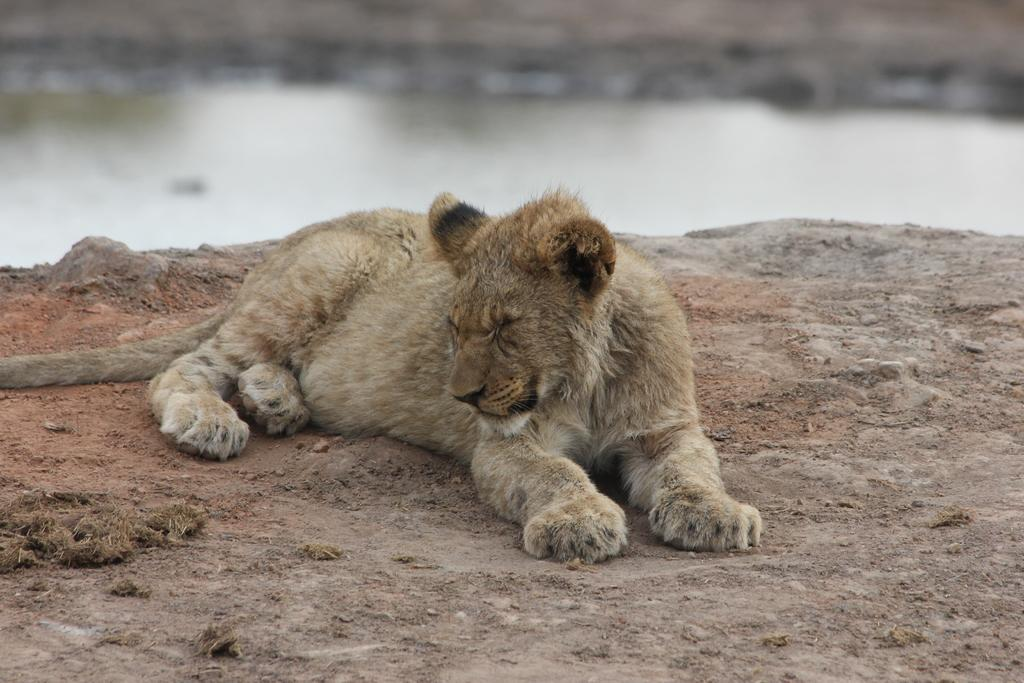What is visible in the image? Water is visible in the image. What type of animal can be seen in the image? There is a brown-colored animal in the image. What type of lead can be seen in the image? There is no lead present in the image. What type of wine can be seen in the image? There is no wine present in the image. 